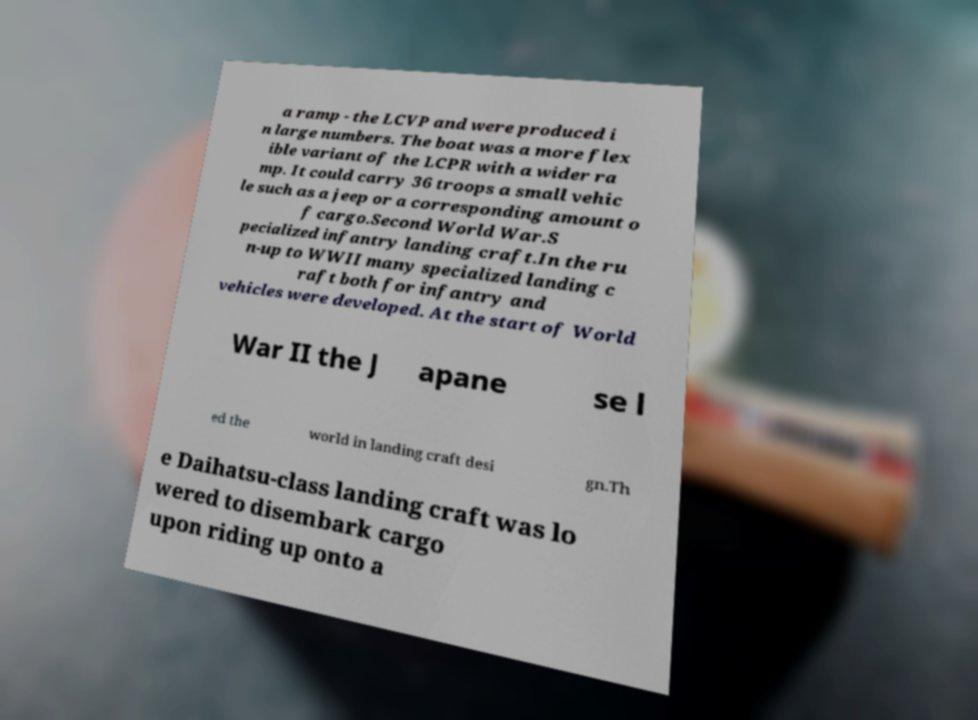Please read and relay the text visible in this image. What does it say? a ramp - the LCVP and were produced i n large numbers. The boat was a more flex ible variant of the LCPR with a wider ra mp. It could carry 36 troops a small vehic le such as a jeep or a corresponding amount o f cargo.Second World War.S pecialized infantry landing craft.In the ru n-up to WWII many specialized landing c raft both for infantry and vehicles were developed. At the start of World War II the J apane se l ed the world in landing craft desi gn.Th e Daihatsu-class landing craft was lo wered to disembark cargo upon riding up onto a 